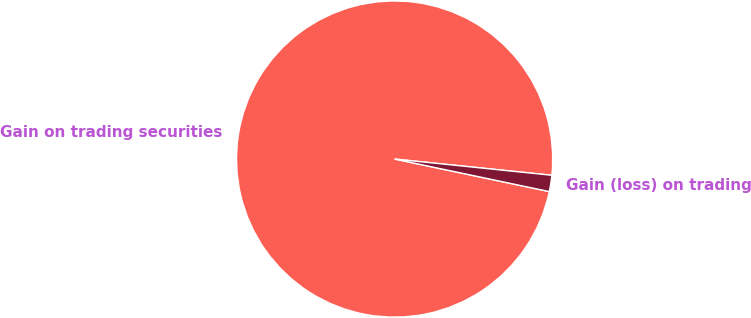<chart> <loc_0><loc_0><loc_500><loc_500><pie_chart><fcel>Gain on trading securities<fcel>Gain (loss) on trading<nl><fcel>98.34%<fcel>1.66%<nl></chart> 